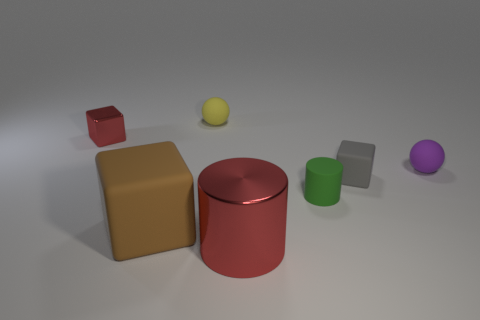How many other things are there of the same color as the big matte block?
Provide a succinct answer. 0. There is a red object in front of the brown thing; is it the same size as the purple matte thing?
Provide a short and direct response. No. Does the small object right of the tiny gray thing have the same material as the ball on the left side of the purple matte sphere?
Your answer should be very brief. Yes. Is there a gray object that has the same size as the purple matte ball?
Make the answer very short. Yes. There is a brown object to the right of the red metal object that is behind the cube right of the large matte block; what is its shape?
Your answer should be compact. Cube. Is the number of cylinders that are behind the brown block greater than the number of purple matte things?
Offer a terse response. No. Are there any tiny yellow rubber objects of the same shape as the large matte thing?
Give a very brief answer. No. Is the tiny yellow ball made of the same material as the cylinder that is behind the large red object?
Provide a succinct answer. Yes. What is the color of the large cylinder?
Your answer should be compact. Red. There is a small ball behind the red shiny object on the left side of the big metal thing; what number of matte blocks are on the left side of it?
Ensure brevity in your answer.  1. 